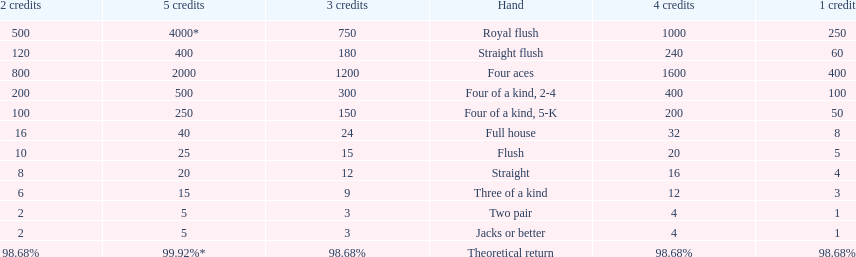What is the total amount of a 3 credit straight flush? 180. 